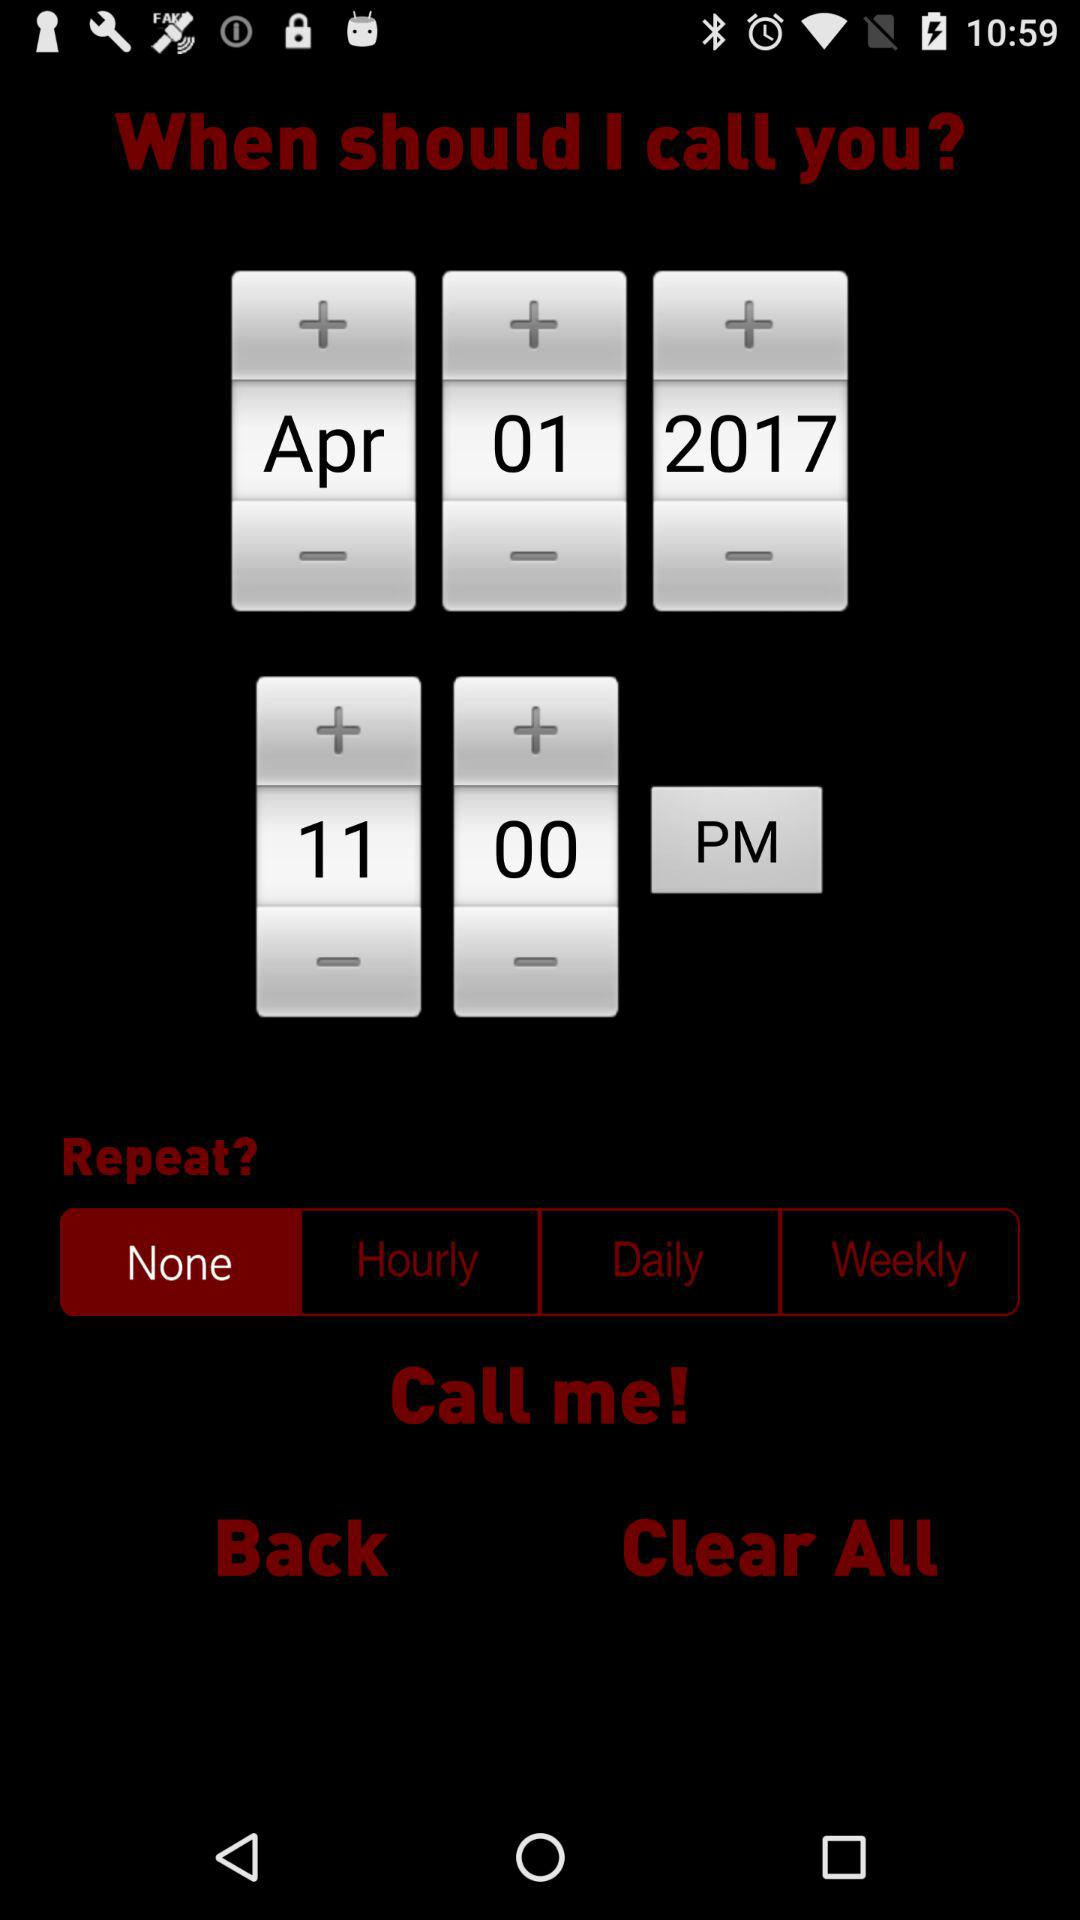What date is selected? The selected date is April 1, 2017. 